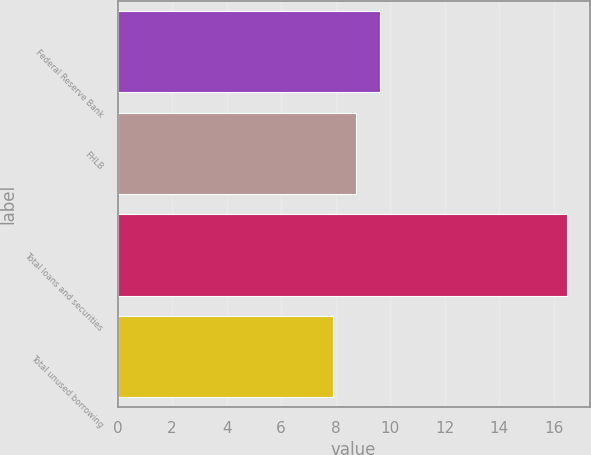<chart> <loc_0><loc_0><loc_500><loc_500><bar_chart><fcel>Federal Reserve Bank<fcel>FHLB<fcel>Total loans and securities<fcel>Total unused borrowing<nl><fcel>9.62<fcel>8.76<fcel>16.5<fcel>7.9<nl></chart> 